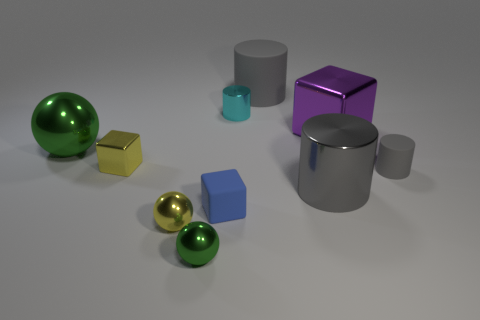Subtract all tiny rubber blocks. How many blocks are left? 2 Subtract all cylinders. How many objects are left? 6 Subtract 3 balls. How many balls are left? 0 Subtract all yellow spheres. How many spheres are left? 2 Subtract all blue cylinders. Subtract all red blocks. How many cylinders are left? 4 Subtract all purple cylinders. How many purple blocks are left? 1 Subtract all cyan metallic objects. Subtract all purple things. How many objects are left? 8 Add 4 purple metallic objects. How many purple metallic objects are left? 5 Add 8 big green metal objects. How many big green metal objects exist? 9 Subtract 0 cyan balls. How many objects are left? 10 